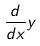Convert formula to latex. <formula><loc_0><loc_0><loc_500><loc_500>\frac { d } { d x } y</formula> 